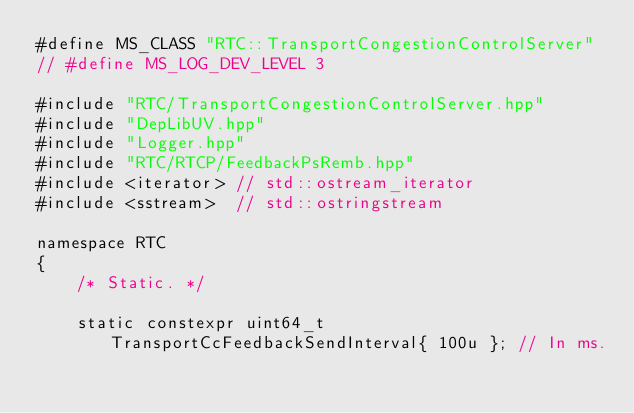<code> <loc_0><loc_0><loc_500><loc_500><_C++_>#define MS_CLASS "RTC::TransportCongestionControlServer"
// #define MS_LOG_DEV_LEVEL 3

#include "RTC/TransportCongestionControlServer.hpp"
#include "DepLibUV.hpp"
#include "Logger.hpp"
#include "RTC/RTCP/FeedbackPsRemb.hpp"
#include <iterator> // std::ostream_iterator
#include <sstream>  // std::ostringstream

namespace RTC
{
	/* Static. */

	static constexpr uint64_t TransportCcFeedbackSendInterval{ 100u }; // In ms.</code> 